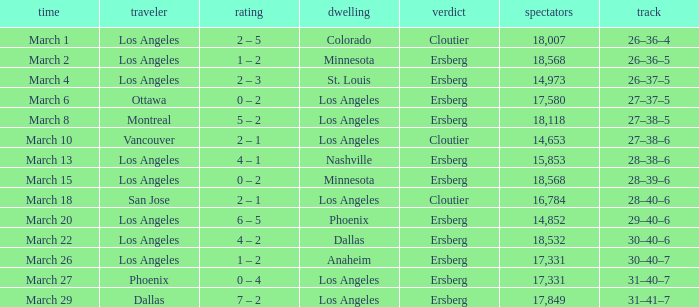Would you be able to parse every entry in this table? {'header': ['time', 'traveler', 'rating', 'dwelling', 'verdict', 'spectators', 'track'], 'rows': [['March 1', 'Los Angeles', '2 – 5', 'Colorado', 'Cloutier', '18,007', '26–36–4'], ['March 2', 'Los Angeles', '1 – 2', 'Minnesota', 'Ersberg', '18,568', '26–36–5'], ['March 4', 'Los Angeles', '2 – 3', 'St. Louis', 'Ersberg', '14,973', '26–37–5'], ['March 6', 'Ottawa', '0 – 2', 'Los Angeles', 'Ersberg', '17,580', '27–37–5'], ['March 8', 'Montreal', '5 – 2', 'Los Angeles', 'Ersberg', '18,118', '27–38–5'], ['March 10', 'Vancouver', '2 – 1', 'Los Angeles', 'Cloutier', '14,653', '27–38–6'], ['March 13', 'Los Angeles', '4 – 1', 'Nashville', 'Ersberg', '15,853', '28–38–6'], ['March 15', 'Los Angeles', '0 – 2', 'Minnesota', 'Ersberg', '18,568', '28–39–6'], ['March 18', 'San Jose', '2 – 1', 'Los Angeles', 'Cloutier', '16,784', '28–40–6'], ['March 20', 'Los Angeles', '6 – 5', 'Phoenix', 'Ersberg', '14,852', '29–40–6'], ['March 22', 'Los Angeles', '4 – 2', 'Dallas', 'Ersberg', '18,532', '30–40–6'], ['March 26', 'Los Angeles', '1 – 2', 'Anaheim', 'Ersberg', '17,331', '30–40–7'], ['March 27', 'Phoenix', '0 – 4', 'Los Angeles', 'Ersberg', '17,331', '31–40–7'], ['March 29', 'Dallas', '7 – 2', 'Los Angeles', 'Ersberg', '17,849', '31–41–7']]} What is the Decision listed when the Home was Colorado? Cloutier. 